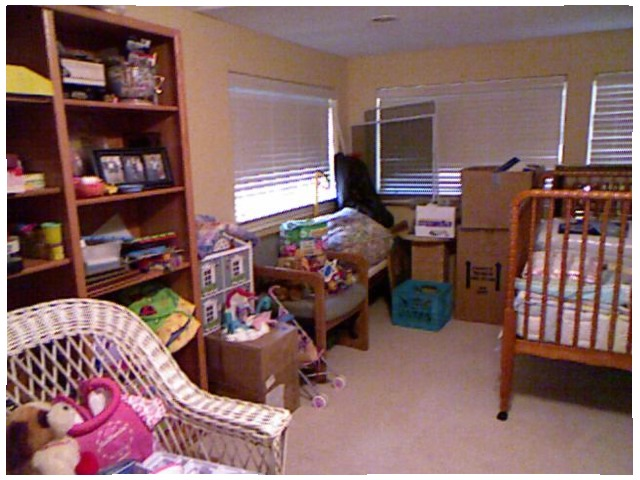<image>
Is there a box on the box? Yes. Looking at the image, I can see the box is positioned on top of the box, with the box providing support. Is there a wicker chair on the book case? No. The wicker chair is not positioned on the book case. They may be near each other, but the wicker chair is not supported by or resting on top of the book case. Is there a buggy to the right of the window? No. The buggy is not to the right of the window. The horizontal positioning shows a different relationship. Is there a table next to the chair? No. The table is not positioned next to the chair. They are located in different areas of the scene. Where is the chair in relation to the toy? Is it next to the toy? No. The chair is not positioned next to the toy. They are located in different areas of the scene. Where is the storage bin in relation to the crib? Is it in the crib? Yes. The storage bin is contained within or inside the crib, showing a containment relationship. Is the light in the window? Yes. The light is contained within or inside the window, showing a containment relationship. 